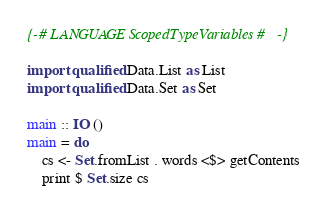Convert code to text. <code><loc_0><loc_0><loc_500><loc_500><_Haskell_>{-# LANGUAGE ScopedTypeVariables #-}

import qualified Data.List as List
import qualified Data.Set as Set

main :: IO ()
main = do
    cs <- Set.fromList . words <$> getContents
    print $ Set.size cs
</code> 